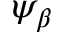<formula> <loc_0><loc_0><loc_500><loc_500>\psi _ { \beta }</formula> 